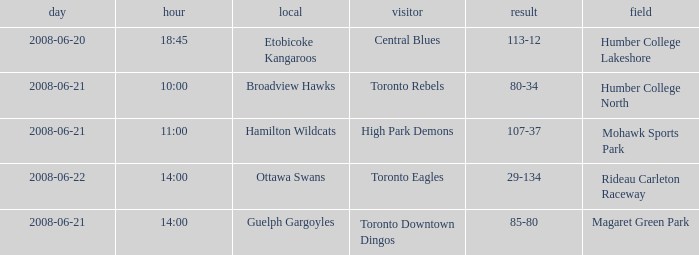What is the Date with a Home that is hamilton wildcats? 2008-06-21. 